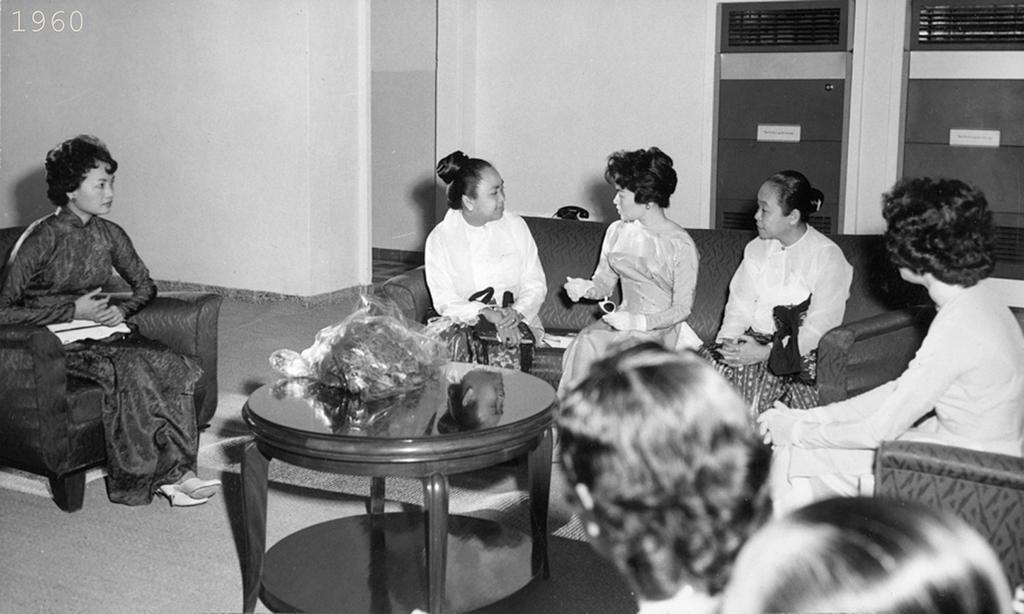Can you describe this image briefly? in this image there are group of woman sitting in a couch and talking to each other , another woman sitting in a chair, and in between all these people there is a table , there is one object in the table and at the background there is door, name board , wall. 